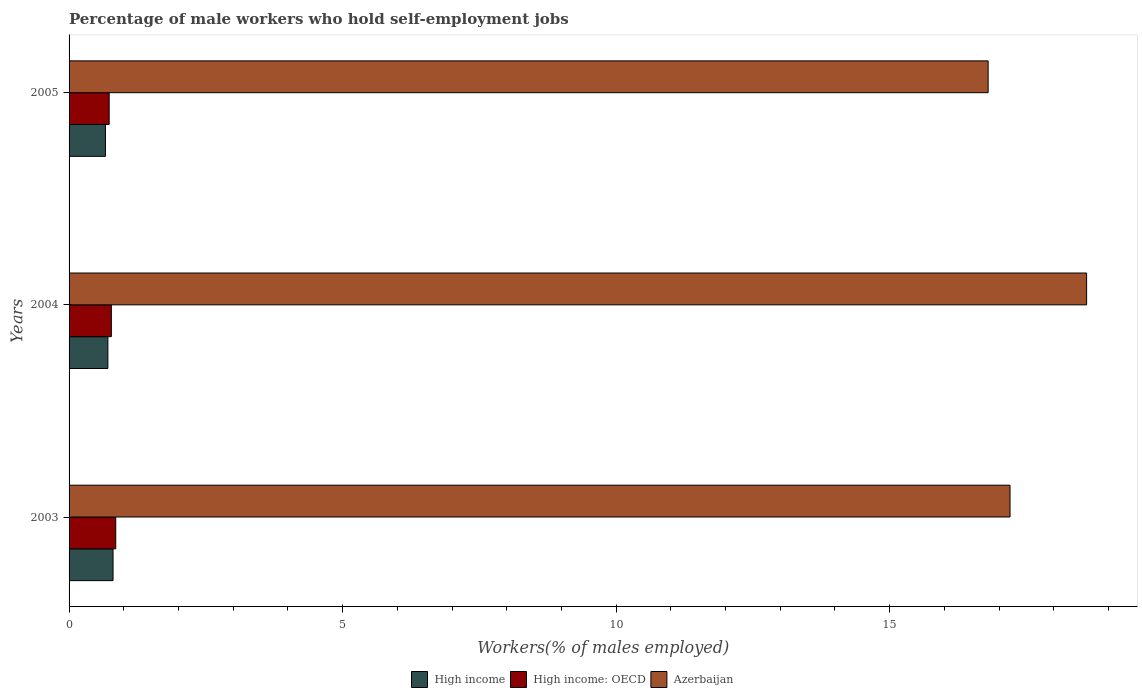How many groups of bars are there?
Provide a succinct answer. 3. Are the number of bars per tick equal to the number of legend labels?
Provide a succinct answer. Yes. Are the number of bars on each tick of the Y-axis equal?
Make the answer very short. Yes. What is the label of the 2nd group of bars from the top?
Provide a short and direct response. 2004. What is the percentage of self-employed male workers in High income in 2004?
Give a very brief answer. 0.71. Across all years, what is the maximum percentage of self-employed male workers in High income?
Your answer should be compact. 0.8. Across all years, what is the minimum percentage of self-employed male workers in Azerbaijan?
Ensure brevity in your answer.  16.8. In which year was the percentage of self-employed male workers in Azerbaijan maximum?
Your answer should be compact. 2004. In which year was the percentage of self-employed male workers in High income minimum?
Your response must be concise. 2005. What is the total percentage of self-employed male workers in Azerbaijan in the graph?
Your response must be concise. 52.6. What is the difference between the percentage of self-employed male workers in Azerbaijan in 2004 and that in 2005?
Offer a terse response. 1.8. What is the difference between the percentage of self-employed male workers in High income: OECD in 2004 and the percentage of self-employed male workers in Azerbaijan in 2003?
Your answer should be compact. -16.43. What is the average percentage of self-employed male workers in High income: OECD per year?
Keep it short and to the point. 0.79. In the year 2003, what is the difference between the percentage of self-employed male workers in Azerbaijan and percentage of self-employed male workers in High income?
Offer a very short reply. 16.4. What is the ratio of the percentage of self-employed male workers in Azerbaijan in 2004 to that in 2005?
Ensure brevity in your answer.  1.11. Is the difference between the percentage of self-employed male workers in Azerbaijan in 2004 and 2005 greater than the difference between the percentage of self-employed male workers in High income in 2004 and 2005?
Your answer should be very brief. Yes. What is the difference between the highest and the second highest percentage of self-employed male workers in Azerbaijan?
Offer a very short reply. 1.4. What is the difference between the highest and the lowest percentage of self-employed male workers in Azerbaijan?
Offer a very short reply. 1.8. In how many years, is the percentage of self-employed male workers in Azerbaijan greater than the average percentage of self-employed male workers in Azerbaijan taken over all years?
Keep it short and to the point. 1. Is the sum of the percentage of self-employed male workers in High income in 2003 and 2005 greater than the maximum percentage of self-employed male workers in High income: OECD across all years?
Provide a succinct answer. Yes. What does the 1st bar from the top in 2005 represents?
Offer a very short reply. Azerbaijan. What does the 1st bar from the bottom in 2005 represents?
Make the answer very short. High income. Is it the case that in every year, the sum of the percentage of self-employed male workers in High income: OECD and percentage of self-employed male workers in Azerbaijan is greater than the percentage of self-employed male workers in High income?
Offer a very short reply. Yes. How many bars are there?
Offer a terse response. 9. Are all the bars in the graph horizontal?
Ensure brevity in your answer.  Yes. What is the difference between two consecutive major ticks on the X-axis?
Your answer should be compact. 5. Are the values on the major ticks of X-axis written in scientific E-notation?
Your answer should be compact. No. How are the legend labels stacked?
Your response must be concise. Horizontal. What is the title of the graph?
Offer a very short reply. Percentage of male workers who hold self-employment jobs. Does "Euro area" appear as one of the legend labels in the graph?
Offer a terse response. No. What is the label or title of the X-axis?
Your response must be concise. Workers(% of males employed). What is the label or title of the Y-axis?
Offer a terse response. Years. What is the Workers(% of males employed) in High income in 2003?
Offer a terse response. 0.8. What is the Workers(% of males employed) in High income: OECD in 2003?
Offer a very short reply. 0.85. What is the Workers(% of males employed) in Azerbaijan in 2003?
Give a very brief answer. 17.2. What is the Workers(% of males employed) of High income in 2004?
Keep it short and to the point. 0.71. What is the Workers(% of males employed) of High income: OECD in 2004?
Provide a succinct answer. 0.77. What is the Workers(% of males employed) of Azerbaijan in 2004?
Your answer should be compact. 18.6. What is the Workers(% of males employed) in High income in 2005?
Make the answer very short. 0.66. What is the Workers(% of males employed) in High income: OECD in 2005?
Offer a terse response. 0.73. What is the Workers(% of males employed) of Azerbaijan in 2005?
Your answer should be compact. 16.8. Across all years, what is the maximum Workers(% of males employed) of High income?
Provide a short and direct response. 0.8. Across all years, what is the maximum Workers(% of males employed) in High income: OECD?
Your answer should be very brief. 0.85. Across all years, what is the maximum Workers(% of males employed) in Azerbaijan?
Your response must be concise. 18.6. Across all years, what is the minimum Workers(% of males employed) in High income?
Give a very brief answer. 0.66. Across all years, what is the minimum Workers(% of males employed) of High income: OECD?
Give a very brief answer. 0.73. Across all years, what is the minimum Workers(% of males employed) of Azerbaijan?
Offer a very short reply. 16.8. What is the total Workers(% of males employed) in High income in the graph?
Your answer should be very brief. 2.18. What is the total Workers(% of males employed) in High income: OECD in the graph?
Make the answer very short. 2.36. What is the total Workers(% of males employed) in Azerbaijan in the graph?
Offer a terse response. 52.6. What is the difference between the Workers(% of males employed) of High income in 2003 and that in 2004?
Keep it short and to the point. 0.09. What is the difference between the Workers(% of males employed) of High income: OECD in 2003 and that in 2004?
Offer a very short reply. 0.08. What is the difference between the Workers(% of males employed) in High income in 2003 and that in 2005?
Your answer should be very brief. 0.14. What is the difference between the Workers(% of males employed) in High income: OECD in 2003 and that in 2005?
Offer a terse response. 0.12. What is the difference between the Workers(% of males employed) of Azerbaijan in 2003 and that in 2005?
Make the answer very short. 0.4. What is the difference between the Workers(% of males employed) in High income in 2004 and that in 2005?
Offer a very short reply. 0.04. What is the difference between the Workers(% of males employed) in High income: OECD in 2004 and that in 2005?
Your response must be concise. 0.04. What is the difference between the Workers(% of males employed) in Azerbaijan in 2004 and that in 2005?
Make the answer very short. 1.8. What is the difference between the Workers(% of males employed) in High income in 2003 and the Workers(% of males employed) in High income: OECD in 2004?
Keep it short and to the point. 0.03. What is the difference between the Workers(% of males employed) of High income in 2003 and the Workers(% of males employed) of Azerbaijan in 2004?
Offer a terse response. -17.8. What is the difference between the Workers(% of males employed) in High income: OECD in 2003 and the Workers(% of males employed) in Azerbaijan in 2004?
Provide a short and direct response. -17.75. What is the difference between the Workers(% of males employed) of High income in 2003 and the Workers(% of males employed) of High income: OECD in 2005?
Your answer should be compact. 0.07. What is the difference between the Workers(% of males employed) of High income in 2003 and the Workers(% of males employed) of Azerbaijan in 2005?
Give a very brief answer. -16. What is the difference between the Workers(% of males employed) in High income: OECD in 2003 and the Workers(% of males employed) in Azerbaijan in 2005?
Your response must be concise. -15.95. What is the difference between the Workers(% of males employed) of High income in 2004 and the Workers(% of males employed) of High income: OECD in 2005?
Your answer should be very brief. -0.02. What is the difference between the Workers(% of males employed) in High income in 2004 and the Workers(% of males employed) in Azerbaijan in 2005?
Your answer should be compact. -16.09. What is the difference between the Workers(% of males employed) in High income: OECD in 2004 and the Workers(% of males employed) in Azerbaijan in 2005?
Offer a very short reply. -16.03. What is the average Workers(% of males employed) in High income per year?
Ensure brevity in your answer.  0.73. What is the average Workers(% of males employed) of High income: OECD per year?
Keep it short and to the point. 0.79. What is the average Workers(% of males employed) in Azerbaijan per year?
Make the answer very short. 17.53. In the year 2003, what is the difference between the Workers(% of males employed) of High income and Workers(% of males employed) of High income: OECD?
Offer a very short reply. -0.05. In the year 2003, what is the difference between the Workers(% of males employed) in High income and Workers(% of males employed) in Azerbaijan?
Offer a very short reply. -16.4. In the year 2003, what is the difference between the Workers(% of males employed) in High income: OECD and Workers(% of males employed) in Azerbaijan?
Give a very brief answer. -16.35. In the year 2004, what is the difference between the Workers(% of males employed) of High income and Workers(% of males employed) of High income: OECD?
Keep it short and to the point. -0.06. In the year 2004, what is the difference between the Workers(% of males employed) in High income and Workers(% of males employed) in Azerbaijan?
Your answer should be compact. -17.89. In the year 2004, what is the difference between the Workers(% of males employed) of High income: OECD and Workers(% of males employed) of Azerbaijan?
Your answer should be very brief. -17.83. In the year 2005, what is the difference between the Workers(% of males employed) of High income and Workers(% of males employed) of High income: OECD?
Make the answer very short. -0.07. In the year 2005, what is the difference between the Workers(% of males employed) of High income and Workers(% of males employed) of Azerbaijan?
Provide a short and direct response. -16.14. In the year 2005, what is the difference between the Workers(% of males employed) of High income: OECD and Workers(% of males employed) of Azerbaijan?
Make the answer very short. -16.07. What is the ratio of the Workers(% of males employed) of High income in 2003 to that in 2004?
Ensure brevity in your answer.  1.13. What is the ratio of the Workers(% of males employed) in High income: OECD in 2003 to that in 2004?
Your answer should be compact. 1.1. What is the ratio of the Workers(% of males employed) of Azerbaijan in 2003 to that in 2004?
Your response must be concise. 0.92. What is the ratio of the Workers(% of males employed) in High income in 2003 to that in 2005?
Provide a succinct answer. 1.21. What is the ratio of the Workers(% of males employed) of High income: OECD in 2003 to that in 2005?
Offer a terse response. 1.16. What is the ratio of the Workers(% of males employed) of Azerbaijan in 2003 to that in 2005?
Your answer should be very brief. 1.02. What is the ratio of the Workers(% of males employed) in High income in 2004 to that in 2005?
Make the answer very short. 1.07. What is the ratio of the Workers(% of males employed) of High income: OECD in 2004 to that in 2005?
Make the answer very short. 1.05. What is the ratio of the Workers(% of males employed) in Azerbaijan in 2004 to that in 2005?
Your answer should be compact. 1.11. What is the difference between the highest and the second highest Workers(% of males employed) in High income?
Your answer should be compact. 0.09. What is the difference between the highest and the second highest Workers(% of males employed) of High income: OECD?
Ensure brevity in your answer.  0.08. What is the difference between the highest and the lowest Workers(% of males employed) in High income?
Provide a succinct answer. 0.14. What is the difference between the highest and the lowest Workers(% of males employed) of High income: OECD?
Keep it short and to the point. 0.12. What is the difference between the highest and the lowest Workers(% of males employed) of Azerbaijan?
Your response must be concise. 1.8. 